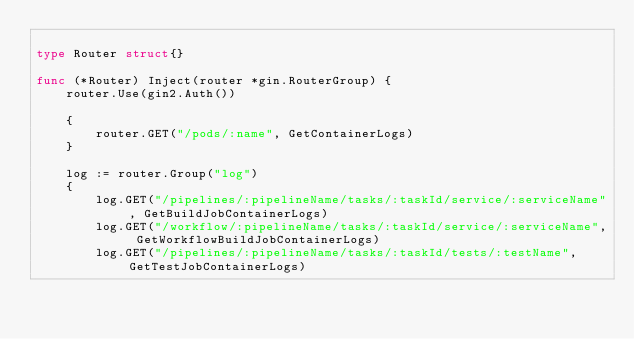<code> <loc_0><loc_0><loc_500><loc_500><_Go_>
type Router struct{}

func (*Router) Inject(router *gin.RouterGroup) {
	router.Use(gin2.Auth())

	{
		router.GET("/pods/:name", GetContainerLogs)
	}

	log := router.Group("log")
	{
		log.GET("/pipelines/:pipelineName/tasks/:taskId/service/:serviceName", GetBuildJobContainerLogs)
		log.GET("/workflow/:pipelineName/tasks/:taskId/service/:serviceName", GetWorkflowBuildJobContainerLogs)
		log.GET("/pipelines/:pipelineName/tasks/:taskId/tests/:testName", GetTestJobContainerLogs)</code> 